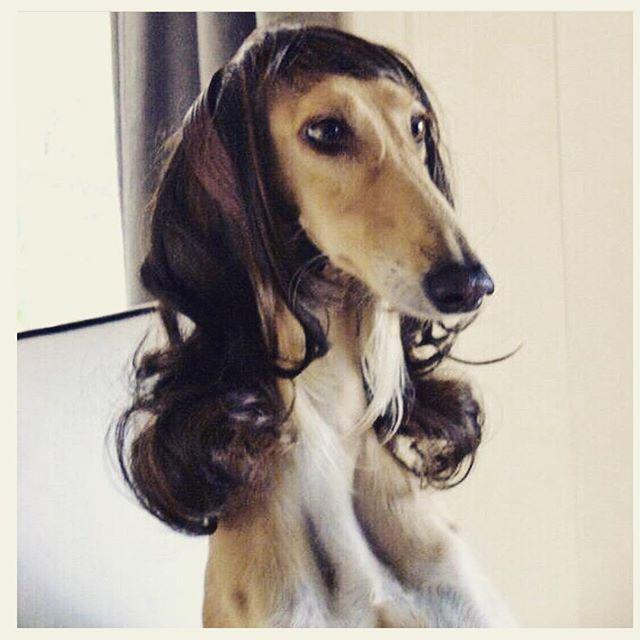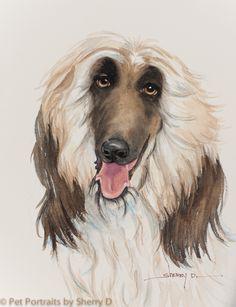The first image is the image on the left, the second image is the image on the right. For the images shown, is this caption "A leash extends diagonally from a top corner to one of the afghan hounds." true? Answer yes or no. No. 